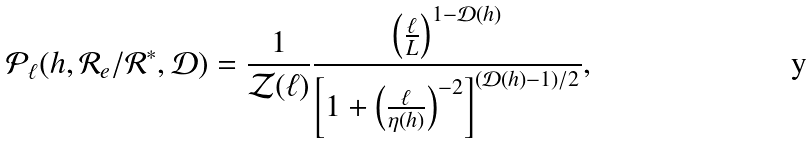<formula> <loc_0><loc_0><loc_500><loc_500>\mathcal { P } _ { \ell } ( h , \mathcal { R } _ { e } / \mathcal { R } ^ { * } , \mathcal { D } ) = \frac { 1 } { \mathcal { Z } ( \ell ) } \frac { \left ( \frac { \ell } { L } \right ) ^ { 1 - \mathcal { D } ( h ) } } { \left [ 1 + \left ( \frac { \ell } { \eta ( h ) } \right ) ^ { - 2 } \right ] ^ { ( \mathcal { D } ( h ) - 1 ) / 2 } } ,</formula> 